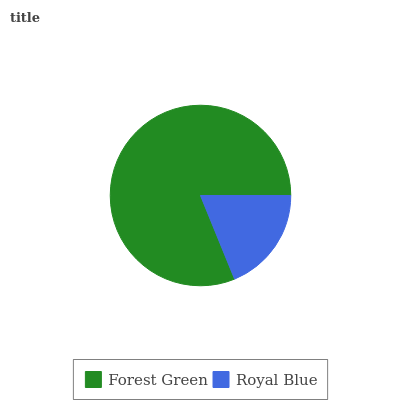Is Royal Blue the minimum?
Answer yes or no. Yes. Is Forest Green the maximum?
Answer yes or no. Yes. Is Royal Blue the maximum?
Answer yes or no. No. Is Forest Green greater than Royal Blue?
Answer yes or no. Yes. Is Royal Blue less than Forest Green?
Answer yes or no. Yes. Is Royal Blue greater than Forest Green?
Answer yes or no. No. Is Forest Green less than Royal Blue?
Answer yes or no. No. Is Forest Green the high median?
Answer yes or no. Yes. Is Royal Blue the low median?
Answer yes or no. Yes. Is Royal Blue the high median?
Answer yes or no. No. Is Forest Green the low median?
Answer yes or no. No. 